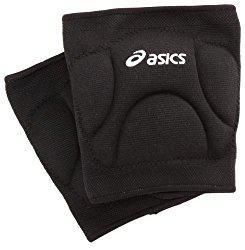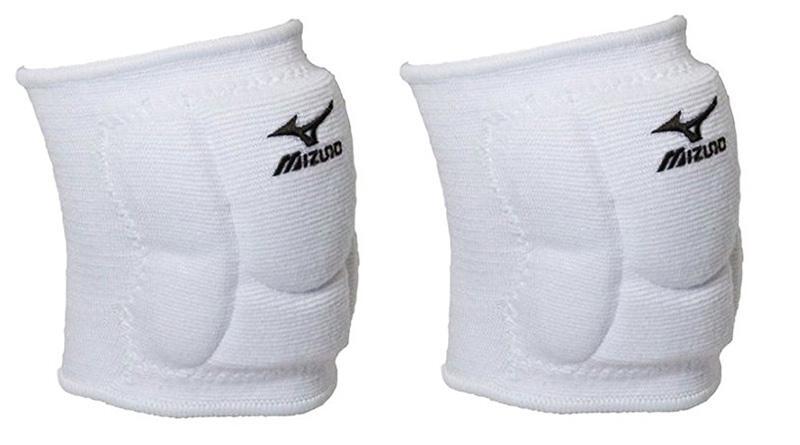The first image is the image on the left, the second image is the image on the right. Assess this claim about the two images: "The combined images include two black knee pads worn on bent human knees that face right.". Correct or not? Answer yes or no. No. The first image is the image on the left, the second image is the image on the right. Considering the images on both sides, is "At least one of the knee braces is white." valid? Answer yes or no. Yes. 